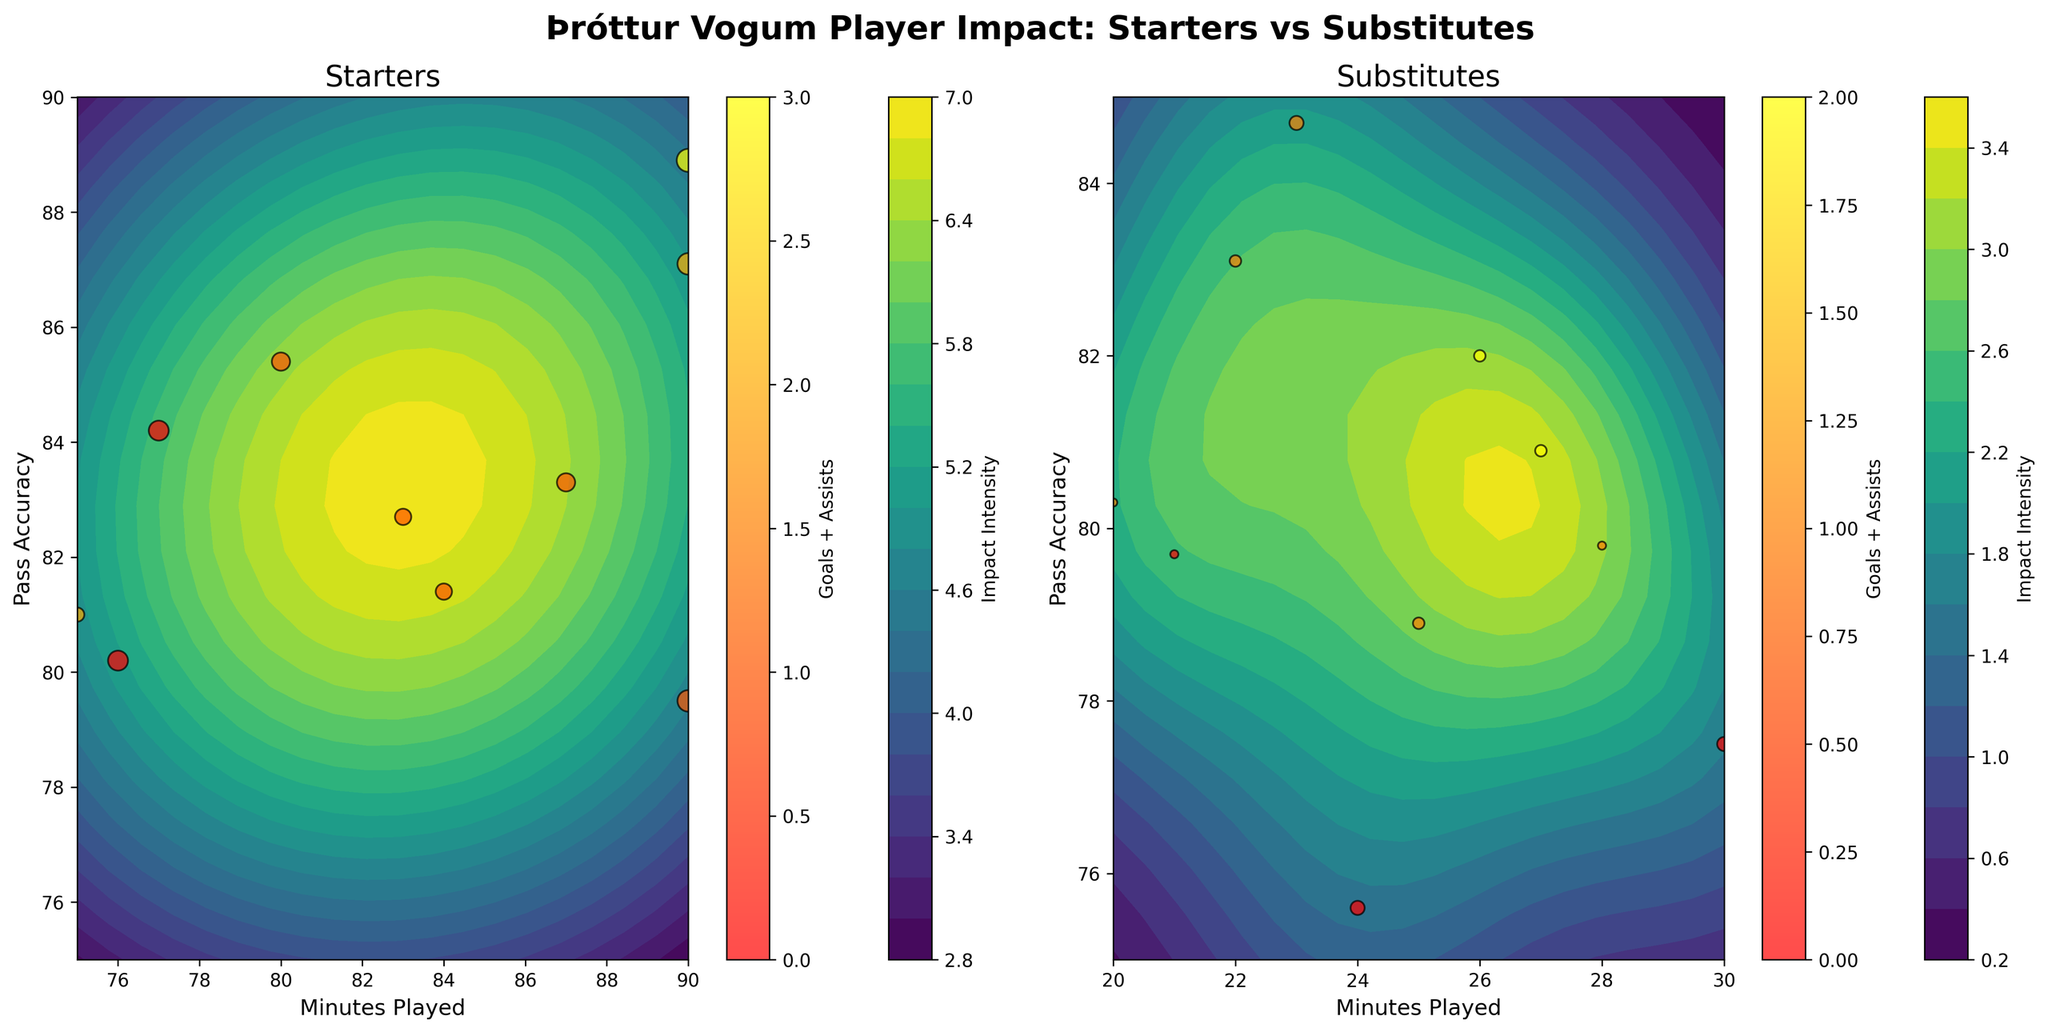What is the title of the figure? The title is displayed at the top of the figure, summarizing the content and comparison being made. The title is "Þróttur Vogum Player Impact: Starters vs Substitutes"
Answer: Þróttur Vogum Player Impact: Starters vs Substitutes Which axis represents 'Minutes Played' for starters and substitutes? The x-axis is labeled with 'Minutes Played' for both subplots (starters and substitutes). This can be observed along the bottom border of each plot with marks and labels indicating the minutes.
Answer: x-axis Which axis represents 'Pass Accuracy' for both players' roles? The y-axis is labeled 'Pass Accuracy' for both the starters and substitutes subplots. This is apparent from the vertical labels on the left side of each plot.
Answer: y-axis What is the approximate maximum 'Pass Accuracy' for substitutes? The y-axis on the subplot for substitutes indicates the pass accuracy levels. The upper limit shown is approximately 85%.
Answer: ~85% How does the 'Impact Intensity' vary for starters compared to substitutes? The 'Impact Intensity' is represented by a contour plot in each subplot. For starters, the intensity is more spread out with a higher range between 75 and 90 minutes and pass accuracy levels around 80-88%. For substitutes, the intensity is concentrated with a range of 20-30 minutes and pass accuracy levels around 75-85%.
Answer: Starters: Spread out, Substitutes: Concentrated How are 'Goals + Assists' visually represented differently for starters and substitutes? 'Goals + Assists' are represented by the color of the scatter plot points in each subplot. The autumn color map indicates varying contributions. For starters, points tend to show more variation in colors, indicating different goals and assists, while substitutes display fewer variations.
Answer: Colors of scatter plot points Which player role has a wider range of 'Pass Accuracy'? By comparing the y-axes range, starters have a wider range of 'Pass Accuracy' from approximately 75% to 90%, while substitutes range from 75% to 85%.
Answer: Starters Which subplot shows players with higher 'Successful Tackles'? The size of the scatter plot points represents successful tackles. The starters' points appear larger, indicating they have more successful tackles compared to substitutes.
Answer: Starters What can be inferred about 'Impact Intensity' in the players from the contour plots? The contour intensity plots show higher concentration of impact in specific areas of the axes. For starters, high impact areas cover a broader region, suggesting varied effectiveness across different playing times and pass accuracies. For substitutes, high impact is concentrated in fewer areas, suggesting specific optimal conditions.
Answer: Starters: Broad, Substitutes: Concentrated 